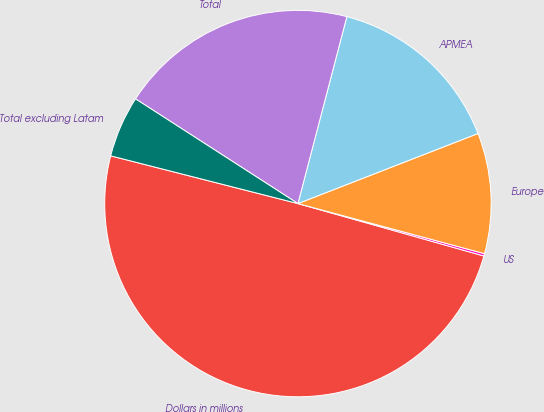Convert chart. <chart><loc_0><loc_0><loc_500><loc_500><pie_chart><fcel>Dollars in millions<fcel>US<fcel>Europe<fcel>APMEA<fcel>Total<fcel>Total excluding Latam<nl><fcel>49.6%<fcel>0.2%<fcel>10.08%<fcel>15.02%<fcel>19.96%<fcel>5.14%<nl></chart> 